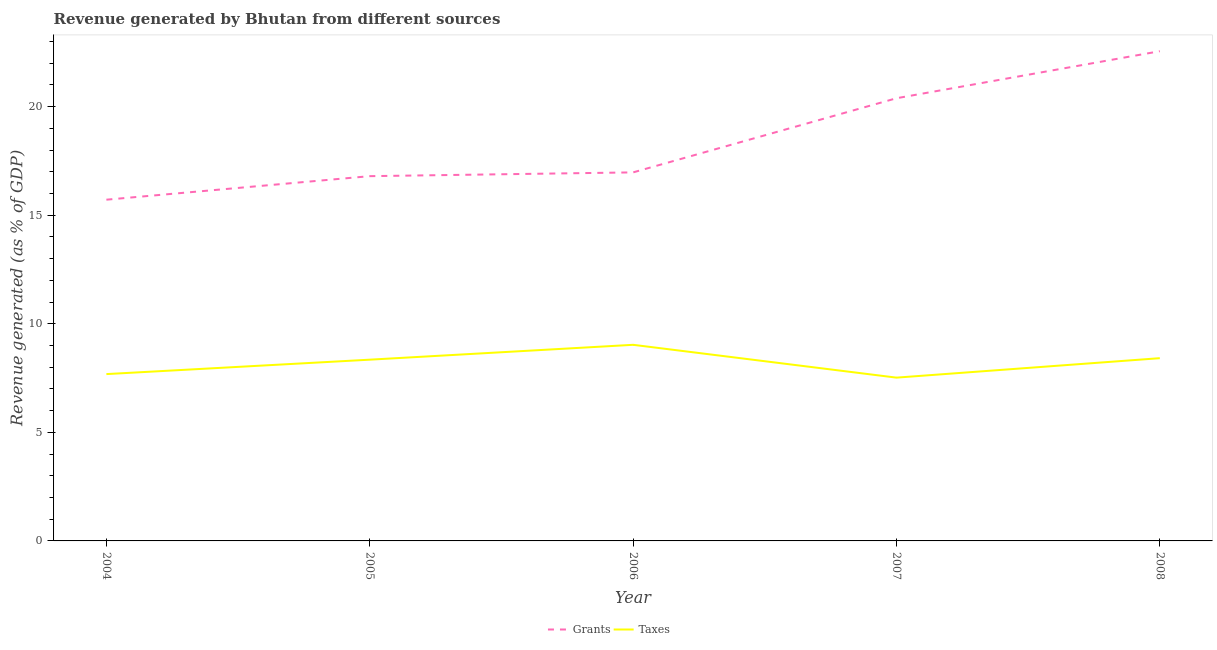How many different coloured lines are there?
Give a very brief answer. 2. What is the revenue generated by grants in 2005?
Provide a short and direct response. 16.8. Across all years, what is the maximum revenue generated by grants?
Keep it short and to the point. 22.55. Across all years, what is the minimum revenue generated by taxes?
Give a very brief answer. 7.52. In which year was the revenue generated by grants maximum?
Make the answer very short. 2008. In which year was the revenue generated by taxes minimum?
Ensure brevity in your answer.  2007. What is the total revenue generated by taxes in the graph?
Ensure brevity in your answer.  41. What is the difference between the revenue generated by grants in 2004 and that in 2007?
Give a very brief answer. -4.67. What is the difference between the revenue generated by taxes in 2007 and the revenue generated by grants in 2005?
Your response must be concise. -9.28. What is the average revenue generated by taxes per year?
Your response must be concise. 8.2. In the year 2006, what is the difference between the revenue generated by grants and revenue generated by taxes?
Provide a short and direct response. 7.94. What is the ratio of the revenue generated by grants in 2005 to that in 2008?
Offer a terse response. 0.74. Is the revenue generated by taxes in 2004 less than that in 2008?
Keep it short and to the point. Yes. What is the difference between the highest and the second highest revenue generated by grants?
Offer a terse response. 2.17. What is the difference between the highest and the lowest revenue generated by grants?
Offer a very short reply. 6.84. In how many years, is the revenue generated by taxes greater than the average revenue generated by taxes taken over all years?
Your response must be concise. 3. Is the sum of the revenue generated by grants in 2004 and 2008 greater than the maximum revenue generated by taxes across all years?
Your answer should be very brief. Yes. Is the revenue generated by taxes strictly greater than the revenue generated by grants over the years?
Your answer should be very brief. No. Is the revenue generated by grants strictly less than the revenue generated by taxes over the years?
Your response must be concise. No. How many lines are there?
Provide a short and direct response. 2. How many years are there in the graph?
Your answer should be compact. 5. What is the difference between two consecutive major ticks on the Y-axis?
Provide a succinct answer. 5. Are the values on the major ticks of Y-axis written in scientific E-notation?
Your answer should be compact. No. Does the graph contain any zero values?
Keep it short and to the point. No. Where does the legend appear in the graph?
Provide a succinct answer. Bottom center. How many legend labels are there?
Make the answer very short. 2. How are the legend labels stacked?
Keep it short and to the point. Horizontal. What is the title of the graph?
Offer a terse response. Revenue generated by Bhutan from different sources. What is the label or title of the X-axis?
Offer a terse response. Year. What is the label or title of the Y-axis?
Your answer should be compact. Revenue generated (as % of GDP). What is the Revenue generated (as % of GDP) in Grants in 2004?
Provide a succinct answer. 15.71. What is the Revenue generated (as % of GDP) in Taxes in 2004?
Make the answer very short. 7.68. What is the Revenue generated (as % of GDP) of Grants in 2005?
Offer a very short reply. 16.8. What is the Revenue generated (as % of GDP) of Taxes in 2005?
Make the answer very short. 8.35. What is the Revenue generated (as % of GDP) in Grants in 2006?
Make the answer very short. 16.97. What is the Revenue generated (as % of GDP) of Taxes in 2006?
Keep it short and to the point. 9.03. What is the Revenue generated (as % of GDP) in Grants in 2007?
Ensure brevity in your answer.  20.39. What is the Revenue generated (as % of GDP) in Taxes in 2007?
Provide a short and direct response. 7.52. What is the Revenue generated (as % of GDP) of Grants in 2008?
Provide a short and direct response. 22.55. What is the Revenue generated (as % of GDP) of Taxes in 2008?
Make the answer very short. 8.42. Across all years, what is the maximum Revenue generated (as % of GDP) in Grants?
Provide a succinct answer. 22.55. Across all years, what is the maximum Revenue generated (as % of GDP) in Taxes?
Provide a succinct answer. 9.03. Across all years, what is the minimum Revenue generated (as % of GDP) of Grants?
Your answer should be very brief. 15.71. Across all years, what is the minimum Revenue generated (as % of GDP) of Taxes?
Provide a succinct answer. 7.52. What is the total Revenue generated (as % of GDP) of Grants in the graph?
Keep it short and to the point. 92.42. What is the total Revenue generated (as % of GDP) in Taxes in the graph?
Ensure brevity in your answer.  41. What is the difference between the Revenue generated (as % of GDP) in Grants in 2004 and that in 2005?
Offer a terse response. -1.08. What is the difference between the Revenue generated (as % of GDP) of Taxes in 2004 and that in 2005?
Provide a succinct answer. -0.66. What is the difference between the Revenue generated (as % of GDP) in Grants in 2004 and that in 2006?
Ensure brevity in your answer.  -1.26. What is the difference between the Revenue generated (as % of GDP) in Taxes in 2004 and that in 2006?
Provide a succinct answer. -1.35. What is the difference between the Revenue generated (as % of GDP) in Grants in 2004 and that in 2007?
Your answer should be very brief. -4.67. What is the difference between the Revenue generated (as % of GDP) of Taxes in 2004 and that in 2007?
Make the answer very short. 0.16. What is the difference between the Revenue generated (as % of GDP) of Grants in 2004 and that in 2008?
Offer a very short reply. -6.84. What is the difference between the Revenue generated (as % of GDP) in Taxes in 2004 and that in 2008?
Offer a terse response. -0.73. What is the difference between the Revenue generated (as % of GDP) of Grants in 2005 and that in 2006?
Offer a very short reply. -0.17. What is the difference between the Revenue generated (as % of GDP) in Taxes in 2005 and that in 2006?
Offer a very short reply. -0.68. What is the difference between the Revenue generated (as % of GDP) of Grants in 2005 and that in 2007?
Provide a succinct answer. -3.59. What is the difference between the Revenue generated (as % of GDP) in Taxes in 2005 and that in 2007?
Your answer should be very brief. 0.83. What is the difference between the Revenue generated (as % of GDP) in Grants in 2005 and that in 2008?
Your answer should be compact. -5.75. What is the difference between the Revenue generated (as % of GDP) in Taxes in 2005 and that in 2008?
Offer a terse response. -0.07. What is the difference between the Revenue generated (as % of GDP) in Grants in 2006 and that in 2007?
Ensure brevity in your answer.  -3.41. What is the difference between the Revenue generated (as % of GDP) of Taxes in 2006 and that in 2007?
Keep it short and to the point. 1.51. What is the difference between the Revenue generated (as % of GDP) in Grants in 2006 and that in 2008?
Your response must be concise. -5.58. What is the difference between the Revenue generated (as % of GDP) of Taxes in 2006 and that in 2008?
Your answer should be compact. 0.62. What is the difference between the Revenue generated (as % of GDP) of Grants in 2007 and that in 2008?
Offer a terse response. -2.17. What is the difference between the Revenue generated (as % of GDP) of Taxes in 2007 and that in 2008?
Provide a short and direct response. -0.9. What is the difference between the Revenue generated (as % of GDP) in Grants in 2004 and the Revenue generated (as % of GDP) in Taxes in 2005?
Make the answer very short. 7.37. What is the difference between the Revenue generated (as % of GDP) in Grants in 2004 and the Revenue generated (as % of GDP) in Taxes in 2006?
Offer a very short reply. 6.68. What is the difference between the Revenue generated (as % of GDP) of Grants in 2004 and the Revenue generated (as % of GDP) of Taxes in 2007?
Keep it short and to the point. 8.19. What is the difference between the Revenue generated (as % of GDP) of Grants in 2004 and the Revenue generated (as % of GDP) of Taxes in 2008?
Provide a short and direct response. 7.3. What is the difference between the Revenue generated (as % of GDP) in Grants in 2005 and the Revenue generated (as % of GDP) in Taxes in 2006?
Your answer should be compact. 7.77. What is the difference between the Revenue generated (as % of GDP) of Grants in 2005 and the Revenue generated (as % of GDP) of Taxes in 2007?
Your response must be concise. 9.28. What is the difference between the Revenue generated (as % of GDP) in Grants in 2005 and the Revenue generated (as % of GDP) in Taxes in 2008?
Provide a succinct answer. 8.38. What is the difference between the Revenue generated (as % of GDP) in Grants in 2006 and the Revenue generated (as % of GDP) in Taxes in 2007?
Keep it short and to the point. 9.45. What is the difference between the Revenue generated (as % of GDP) of Grants in 2006 and the Revenue generated (as % of GDP) of Taxes in 2008?
Your response must be concise. 8.56. What is the difference between the Revenue generated (as % of GDP) in Grants in 2007 and the Revenue generated (as % of GDP) in Taxes in 2008?
Offer a terse response. 11.97. What is the average Revenue generated (as % of GDP) in Grants per year?
Give a very brief answer. 18.48. What is the average Revenue generated (as % of GDP) of Taxes per year?
Your response must be concise. 8.2. In the year 2004, what is the difference between the Revenue generated (as % of GDP) in Grants and Revenue generated (as % of GDP) in Taxes?
Make the answer very short. 8.03. In the year 2005, what is the difference between the Revenue generated (as % of GDP) in Grants and Revenue generated (as % of GDP) in Taxes?
Offer a very short reply. 8.45. In the year 2006, what is the difference between the Revenue generated (as % of GDP) of Grants and Revenue generated (as % of GDP) of Taxes?
Your answer should be very brief. 7.94. In the year 2007, what is the difference between the Revenue generated (as % of GDP) in Grants and Revenue generated (as % of GDP) in Taxes?
Offer a terse response. 12.87. In the year 2008, what is the difference between the Revenue generated (as % of GDP) of Grants and Revenue generated (as % of GDP) of Taxes?
Give a very brief answer. 14.14. What is the ratio of the Revenue generated (as % of GDP) of Grants in 2004 to that in 2005?
Provide a succinct answer. 0.94. What is the ratio of the Revenue generated (as % of GDP) in Taxes in 2004 to that in 2005?
Provide a short and direct response. 0.92. What is the ratio of the Revenue generated (as % of GDP) of Grants in 2004 to that in 2006?
Provide a short and direct response. 0.93. What is the ratio of the Revenue generated (as % of GDP) of Taxes in 2004 to that in 2006?
Keep it short and to the point. 0.85. What is the ratio of the Revenue generated (as % of GDP) of Grants in 2004 to that in 2007?
Offer a terse response. 0.77. What is the ratio of the Revenue generated (as % of GDP) of Taxes in 2004 to that in 2007?
Ensure brevity in your answer.  1.02. What is the ratio of the Revenue generated (as % of GDP) in Grants in 2004 to that in 2008?
Keep it short and to the point. 0.7. What is the ratio of the Revenue generated (as % of GDP) in Taxes in 2004 to that in 2008?
Keep it short and to the point. 0.91. What is the ratio of the Revenue generated (as % of GDP) of Grants in 2005 to that in 2006?
Offer a very short reply. 0.99. What is the ratio of the Revenue generated (as % of GDP) of Taxes in 2005 to that in 2006?
Make the answer very short. 0.92. What is the ratio of the Revenue generated (as % of GDP) in Grants in 2005 to that in 2007?
Provide a short and direct response. 0.82. What is the ratio of the Revenue generated (as % of GDP) in Taxes in 2005 to that in 2007?
Offer a terse response. 1.11. What is the ratio of the Revenue generated (as % of GDP) of Grants in 2005 to that in 2008?
Your response must be concise. 0.74. What is the ratio of the Revenue generated (as % of GDP) of Taxes in 2005 to that in 2008?
Make the answer very short. 0.99. What is the ratio of the Revenue generated (as % of GDP) in Grants in 2006 to that in 2007?
Make the answer very short. 0.83. What is the ratio of the Revenue generated (as % of GDP) in Taxes in 2006 to that in 2007?
Your response must be concise. 1.2. What is the ratio of the Revenue generated (as % of GDP) of Grants in 2006 to that in 2008?
Give a very brief answer. 0.75. What is the ratio of the Revenue generated (as % of GDP) of Taxes in 2006 to that in 2008?
Keep it short and to the point. 1.07. What is the ratio of the Revenue generated (as % of GDP) in Grants in 2007 to that in 2008?
Ensure brevity in your answer.  0.9. What is the ratio of the Revenue generated (as % of GDP) of Taxes in 2007 to that in 2008?
Keep it short and to the point. 0.89. What is the difference between the highest and the second highest Revenue generated (as % of GDP) of Grants?
Make the answer very short. 2.17. What is the difference between the highest and the second highest Revenue generated (as % of GDP) of Taxes?
Give a very brief answer. 0.62. What is the difference between the highest and the lowest Revenue generated (as % of GDP) of Grants?
Keep it short and to the point. 6.84. What is the difference between the highest and the lowest Revenue generated (as % of GDP) in Taxes?
Provide a succinct answer. 1.51. 